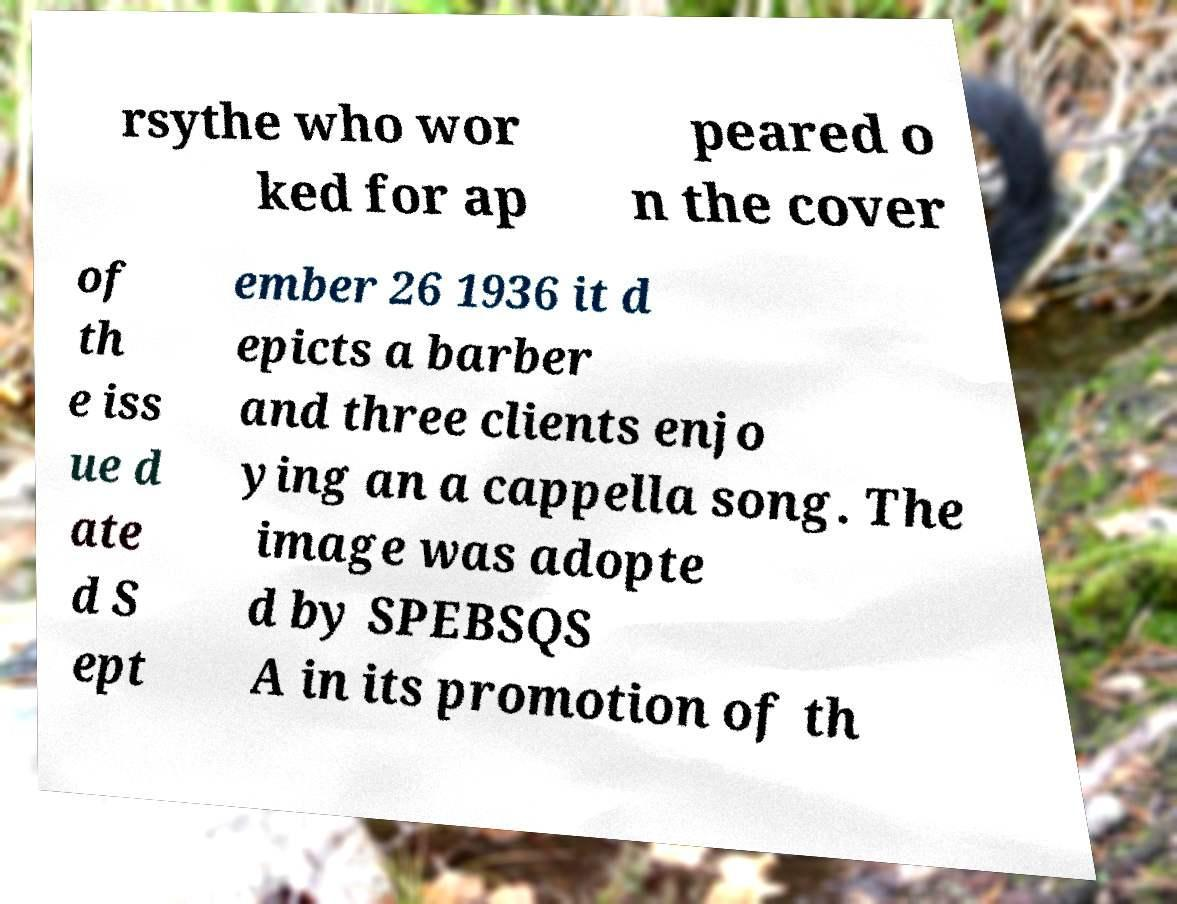I need the written content from this picture converted into text. Can you do that? rsythe who wor ked for ap peared o n the cover of th e iss ue d ate d S ept ember 26 1936 it d epicts a barber and three clients enjo ying an a cappella song. The image was adopte d by SPEBSQS A in its promotion of th 